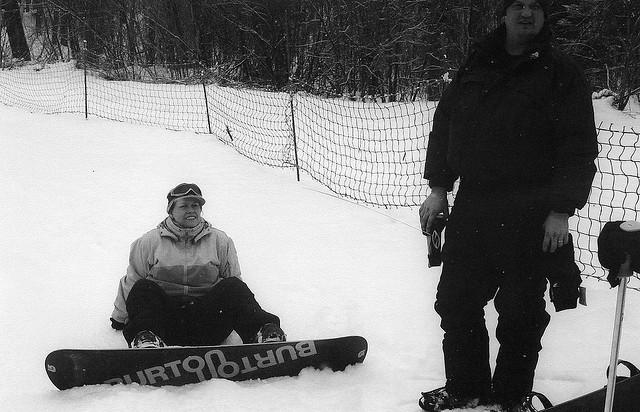Are the people cold?
Concise answer only. Yes. Which brand is the snowboard?
Give a very brief answer. Burton. Do you usually enjoy this sport in warm weather?
Be succinct. No. 